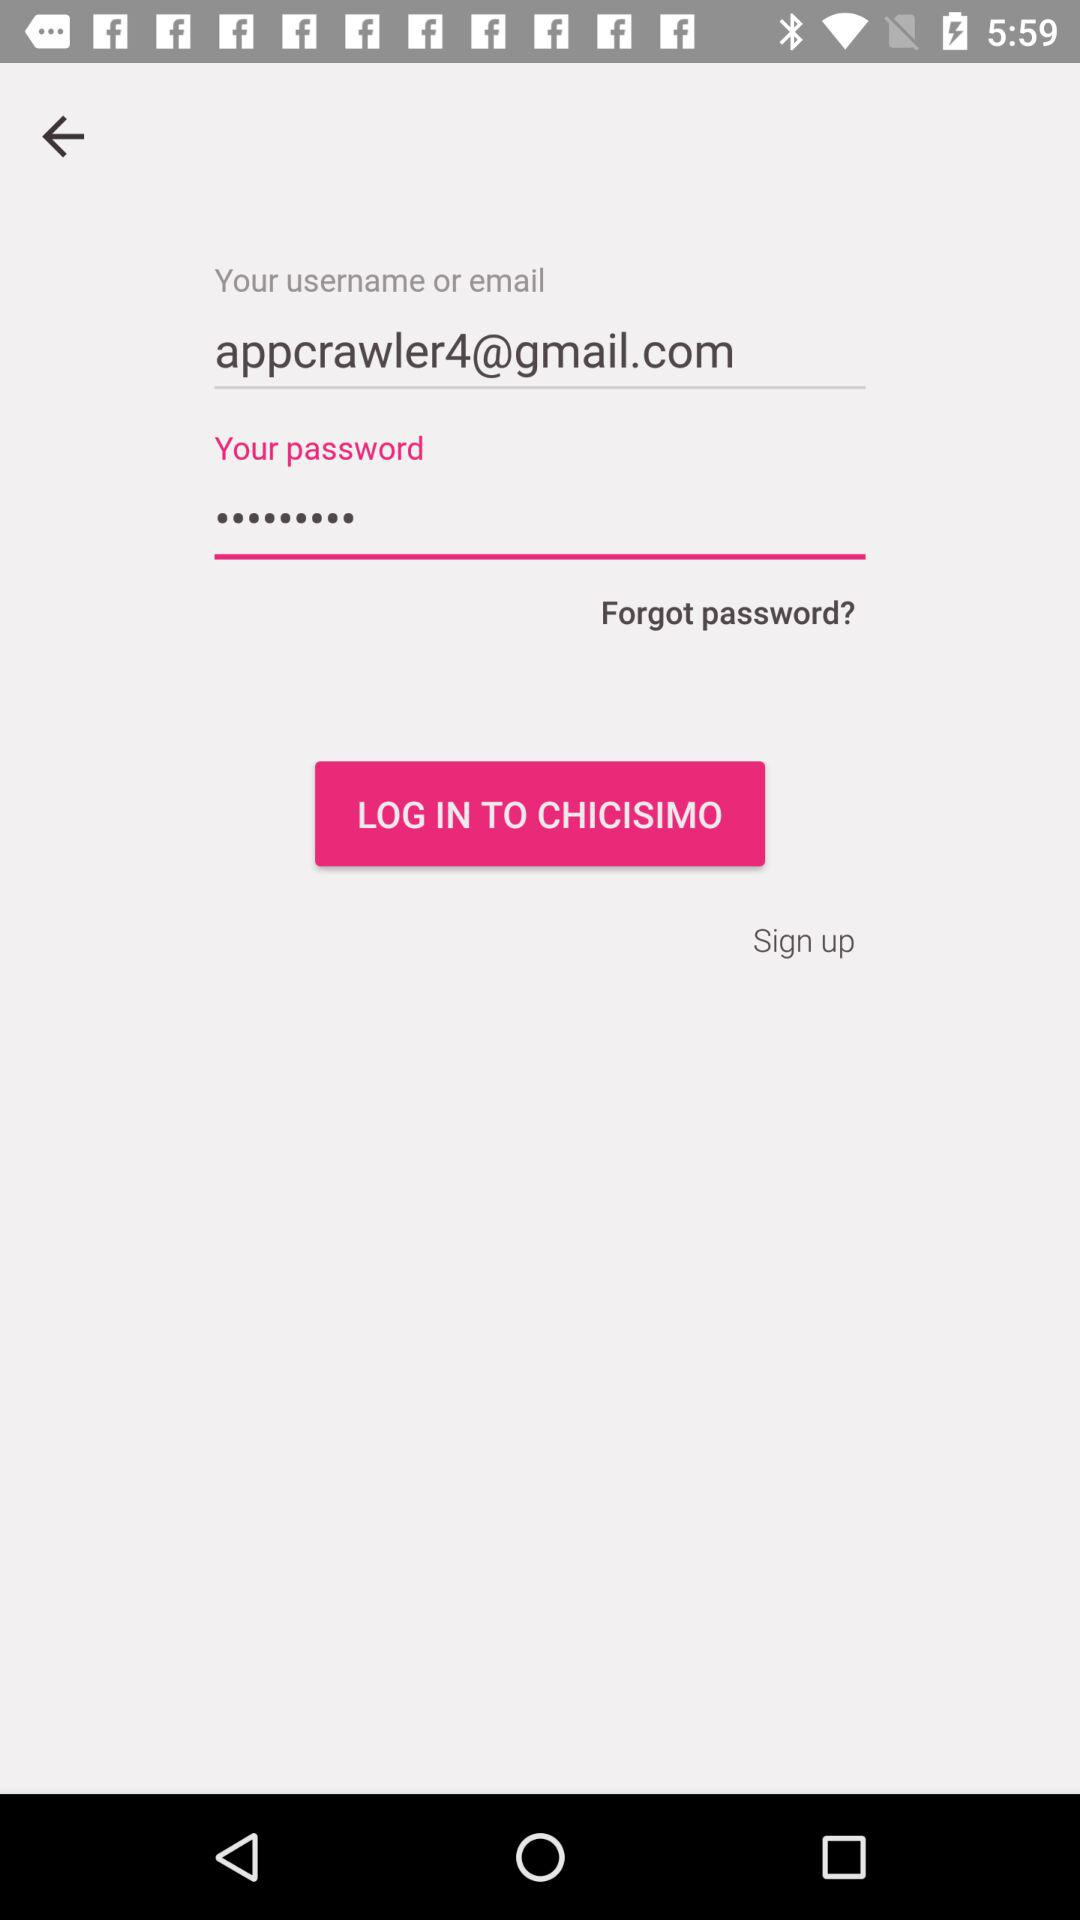What is the name of the user? The name of the user is "appcrawler4@gmail.com". 